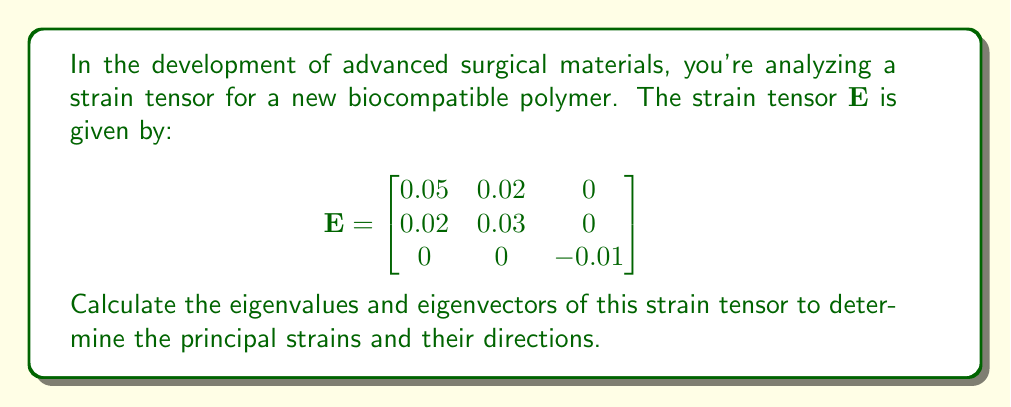Help me with this question. To find the eigenvalues and eigenvectors of the strain tensor $\mathbf{E}$, we follow these steps:

1) First, we calculate the characteristic equation:
   $det(\mathbf{E} - \lambda \mathbf{I}) = 0$

2) Expanding the determinant:
   $$\begin{vmatrix}
   0.05-\lambda & 0.02 & 0 \\
   0.02 & 0.03-\lambda & 0 \\
   0 & 0 & -0.01-\lambda
   \end{vmatrix} = 0$$

3) This gives us:
   $(0.05-\lambda)(0.03-\lambda)(-0.01-\lambda) - 0.02^2(-0.01-\lambda) = 0$

4) Simplifying:
   $-\lambda^3 + 0.07\lambda^2 + 0.0015\lambda - 0.000015 - 0.0004\lambda + 0.000004 = 0$
   $-\lambda^3 + 0.07\lambda^2 + 0.0011\lambda - 0.000011 = 0$

5) Solving this cubic equation (using a computer algebra system), we get the eigenvalues:
   $\lambda_1 \approx 0.0623$
   $\lambda_2 \approx 0.0177$
   $\lambda_3 \approx -0.01$

6) For each eigenvalue, we solve $(\mathbf{E} - \lambda_i \mathbf{I})\mathbf{v}_i = \mathbf{0}$ to find the corresponding eigenvector.

7) For $\lambda_1 \approx 0.0623$:
   $$\begin{bmatrix}
   -0.0123 & 0.02 & 0 \\
   0.02 & -0.0323 & 0 \\
   0 & 0 & -0.0723
   \end{bmatrix}\mathbf{v}_1 = \mathbf{0}$$
   Solving this gives us: $\mathbf{v}_1 \approx (0.7071, 0.7071, 0)$

8) For $\lambda_2 \approx 0.0177$:
   $$\begin{bmatrix}
   0.0323 & 0.02 & 0 \\
   0.02 & 0.0123 & 0 \\
   0 & 0 & -0.0277
   \end{bmatrix}\mathbf{v}_2 = \mathbf{0}$$
   Solving this gives us: $\mathbf{v}_2 \approx (-0.7071, 0.7071, 0)$

9) For $\lambda_3 = -0.01$:
   $$\begin{bmatrix}
   0.06 & 0.02 & 0 \\
   0.02 & 0.04 & 0 \\
   0 & 0 & 0
   \end{bmatrix}\mathbf{v}_3 = \mathbf{0}$$
   Solving this gives us: $\mathbf{v}_3 = (0, 0, 1)$
Answer: Eigenvalues: $\lambda_1 \approx 0.0623$, $\lambda_2 \approx 0.0177$, $\lambda_3 = -0.01$
Eigenvectors: $\mathbf{v}_1 \approx (0.7071, 0.7071, 0)$, $\mathbf{v}_2 \approx (-0.7071, 0.7071, 0)$, $\mathbf{v}_3 = (0, 0, 1)$ 